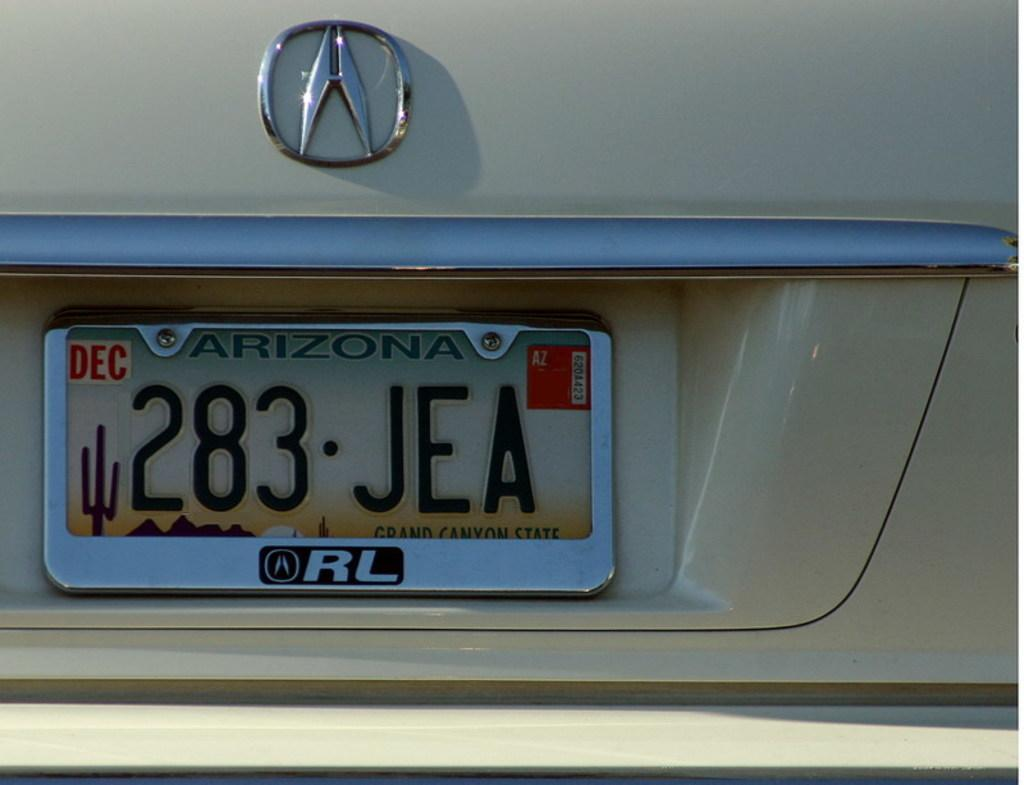<image>
Provide a brief description of the given image. the arizona license plate 283 JEA expires in December 